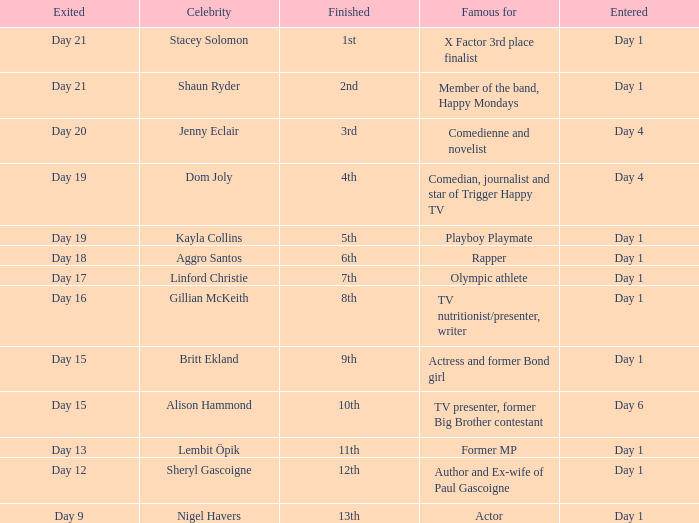What celebrity is famous for being an actor? Nigel Havers. 